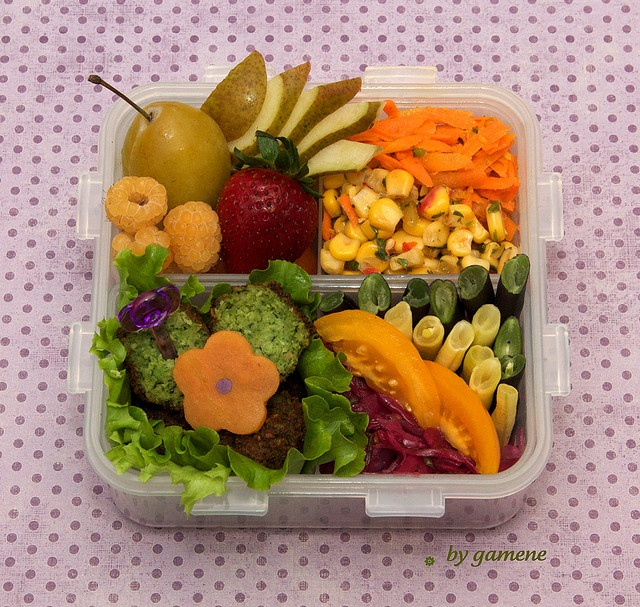Describe the objects in this image and their specific colors. I can see dining table in pink, darkgray, and olive tones, bowl in pink, olive, black, and red tones, carrot in pink, red, orange, and brown tones, broccoli in pink and olive tones, and broccoli in pink, olive, black, maroon, and darkgreen tones in this image. 